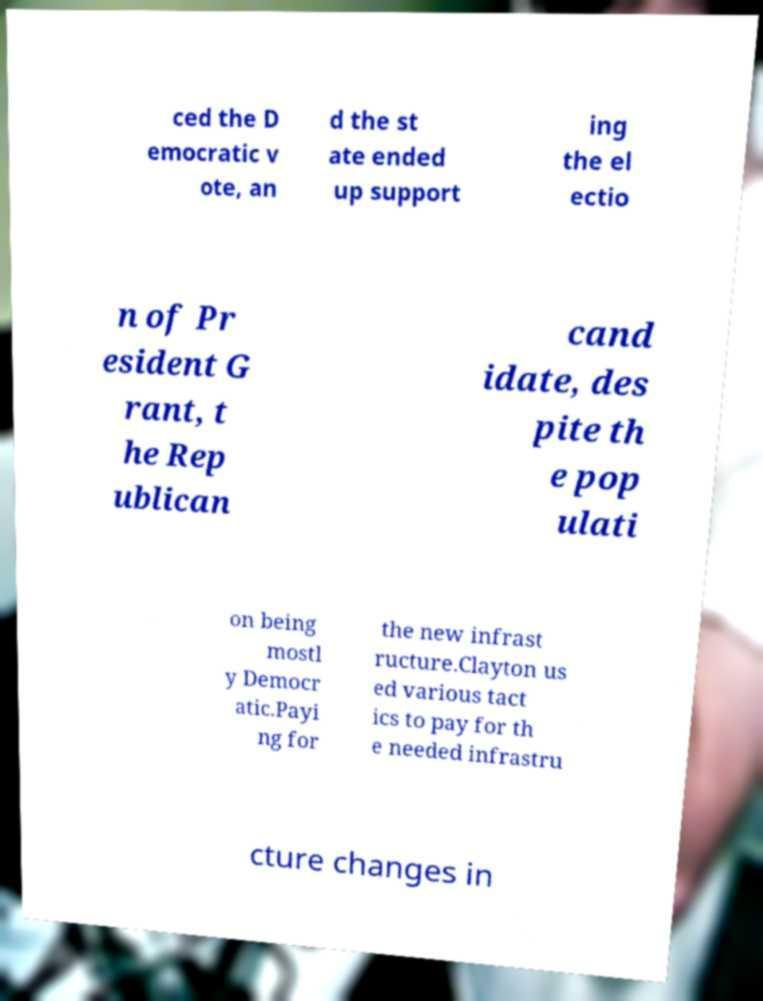What messages or text are displayed in this image? I need them in a readable, typed format. ced the D emocratic v ote, an d the st ate ended up support ing the el ectio n of Pr esident G rant, t he Rep ublican cand idate, des pite th e pop ulati on being mostl y Democr atic.Payi ng for the new infrast ructure.Clayton us ed various tact ics to pay for th e needed infrastru cture changes in 